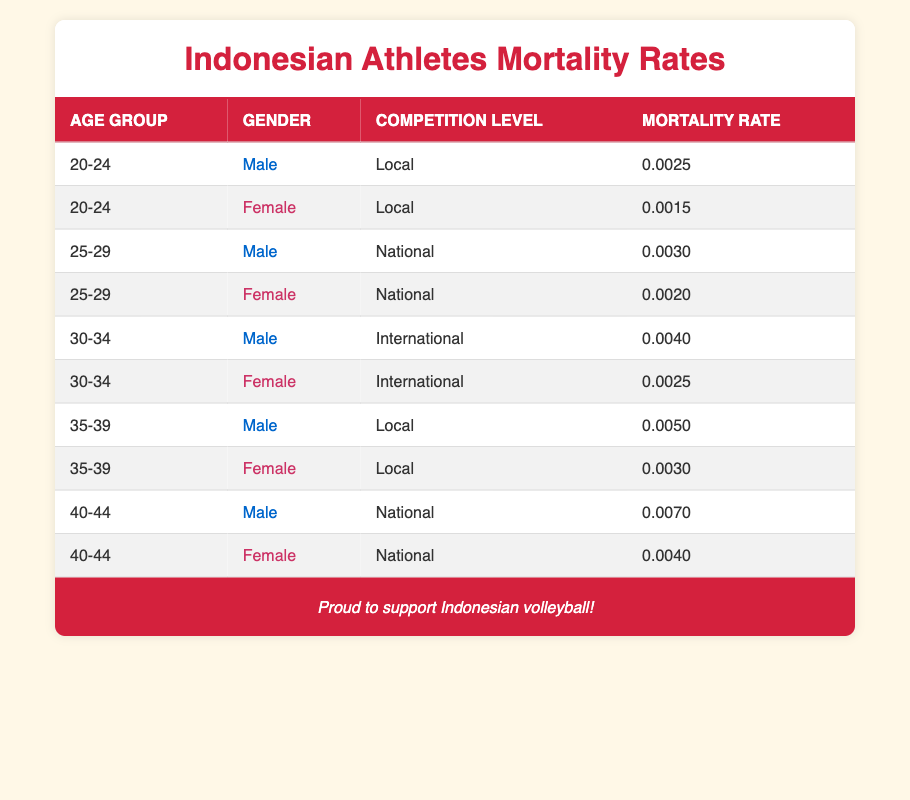What is the mortality rate for male athletes in the 20-24 age group competing at the local level? Referring to the table, the specific entry for male athletes aged 20-24 competing locally shows a mortality rate of 0.0025.
Answer: 0.0025 What is the mortality rate for female athletes competing at the national level in the 25-29 age group? The table indicates that for female athletes aged 25-29 competing at the national level, the mortality rate is recorded as 0.0020.
Answer: 0.0020 Is the mortality rate for male athletes in the 30-34 age group higher than that of female athletes in the same age group competing internationally? By comparing the two rates, the male athletes have a mortality rate of 0.0040, while female athletes have a rate of 0.0025, which confirms that the male rate is higher.
Answer: Yes What is the difference in mortality rates between male and female athletes in the 35-39 age group competing at local competitions? The mortality rate for male athletes in this group is 0.0050 while for females it is 0.0030. The difference is calculated as 0.0050 - 0.0030 = 0.0020.
Answer: 0.0020 What is the average mortality rate for male athletes across all age groups and competition levels? To find the average, sum all the male mortality rates: 0.0025 + 0.0030 + 0.0040 + 0.0050 + 0.0070 = 0.0215. Then divide by the number of entries (5), which gives 0.0215 / 5 = 0.0043.
Answer: 0.0043 Are there any age groups where female athletes have a higher mortality rate than male athletes? By inspecting the data, for the age groups 20-24 and 25-29 in local and national competitions, respectively, male athletes consistently have lower mortality rates, confirming that there are no instances of higher rates for females.
Answer: No What is the total mortality rate for female athletes across all age groups and competition levels? Adding the female mortality rates: 0.0015 + 0.0020 + 0.0025 + 0.0030 + 0.0040 = 0.0130 provides the total female mortality rate across all age groups.
Answer: 0.0130 How does the mortality rate for male athletes in the 40-44 age group compare to that of female athletes in the same age group competing at the national level? The male athletes' mortality rate is 0.0070 while the female athletes’ rate is 0.0040. Thus, the male rate is higher by 0.0070 - 0.0040 = 0.0030.
Answer: Male rate is higher What is the mortality rate for female athletes aged 30-34 competing at the international level? The table specifies that for female athletes in this age group and competition level, the mortality rate is 0.0025.
Answer: 0.0025 